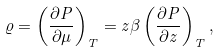<formula> <loc_0><loc_0><loc_500><loc_500>\varrho = \left ( \frac { \partial P } { \partial \mu } \right ) _ { T } = z \beta \left ( \frac { \partial P } { \partial z } \right ) _ { T } ,</formula> 